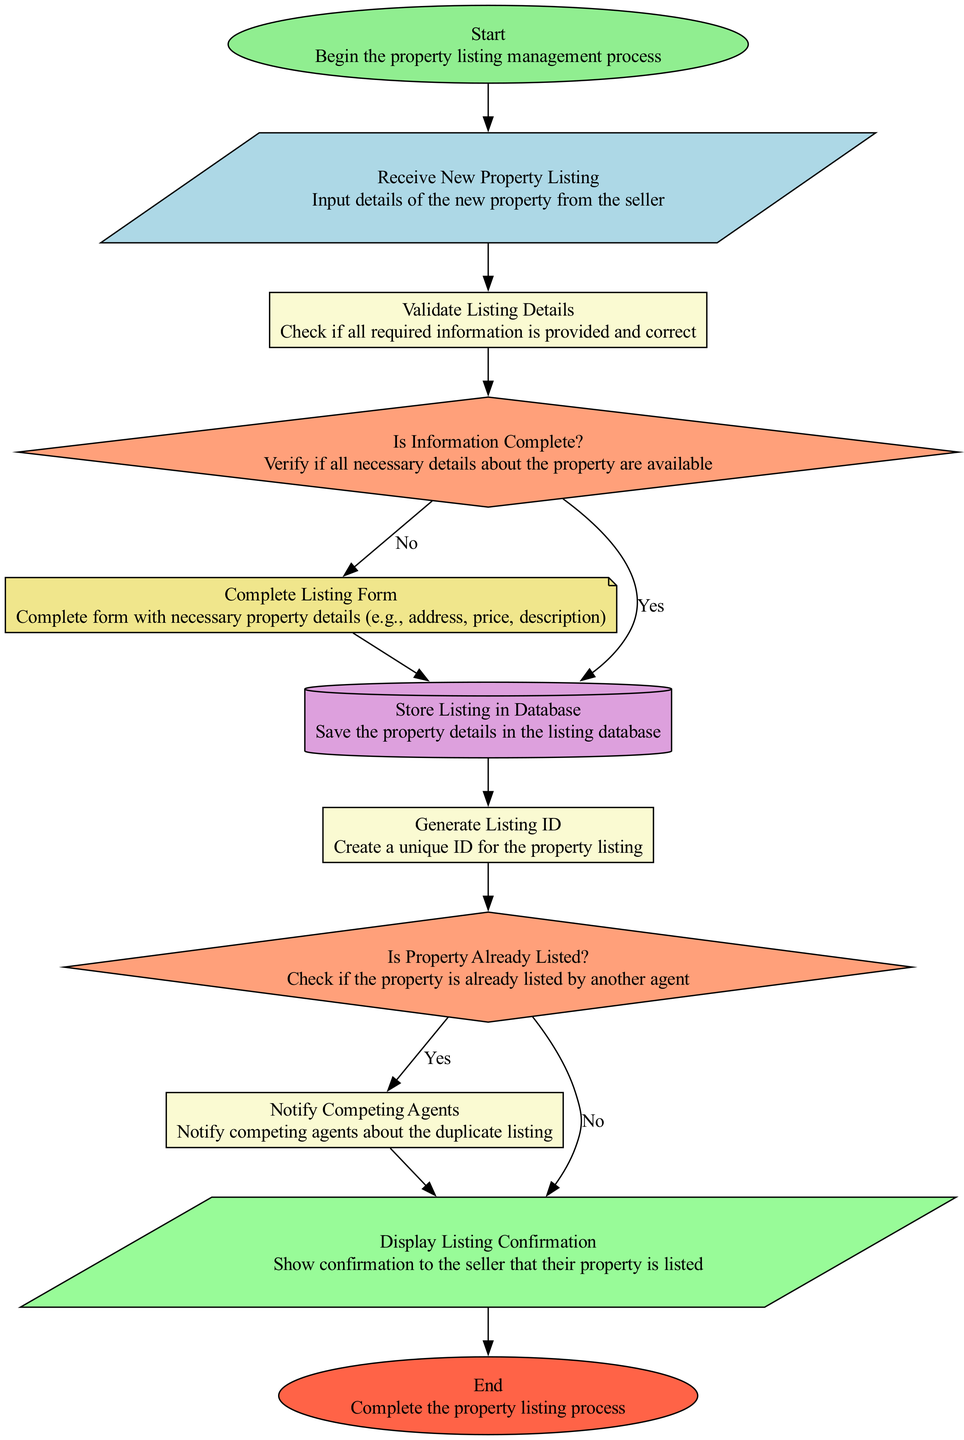What is the first step in the flowchart? The first step in the flowchart is labeled as "Start," indicating the beginning of the property listing management process.
Answer: Start How many decision nodes are present in the diagram? There are two decision nodes labeled "Is Information Complete?" and "Is Property Already Listed?" indicating critical points of verification in the process.
Answer: 2 What document is created after validating listing details? After validating the listing details, the next document created is the "Complete Listing Form," which contains all necessary property details.
Answer: Complete Listing Form What happens if the information is not complete? If the information is not complete, the flowchart directs to the node "Complete Listing Form," indicating that the necessary details must be provided before proceeding.
Answer: Complete Listing Form What does the flowchart ultimately display to the seller? The flowchart ultimately displays the "Display Listing Confirmation" node to the seller, confirming that their property has been listed successfully.
Answer: Display Listing Confirmation What process occurs after storing the listing in the database? After storing the listing in the database, the process that occurs is "Generate Listing ID," where a unique ID is created for the property listing.
Answer: Generate Listing ID What action is taken if a property is already listed by another agent? If a property is already listed by another agent, the flowchart indicates that the system will "Notify Competing Agents" about the duplicate listing.
Answer: Notify Competing Agents How many edges connect to the "Display Listing Confirmation" node? There are three edges connecting to the "Display Listing Confirmation" node; two from decisions whether the information is complete or if the property is already listed, and one from notifying competing agents.
Answer: 3 